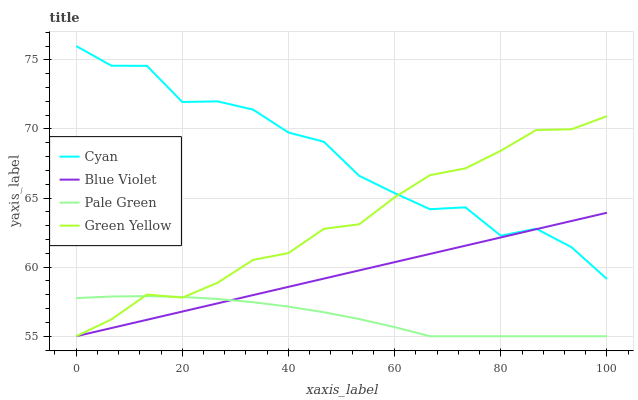Does Green Yellow have the minimum area under the curve?
Answer yes or no. No. Does Green Yellow have the maximum area under the curve?
Answer yes or no. No. Is Green Yellow the smoothest?
Answer yes or no. No. Is Green Yellow the roughest?
Answer yes or no. No. Does Green Yellow have the highest value?
Answer yes or no. No. Is Pale Green less than Cyan?
Answer yes or no. Yes. Is Cyan greater than Pale Green?
Answer yes or no. Yes. Does Pale Green intersect Cyan?
Answer yes or no. No. 